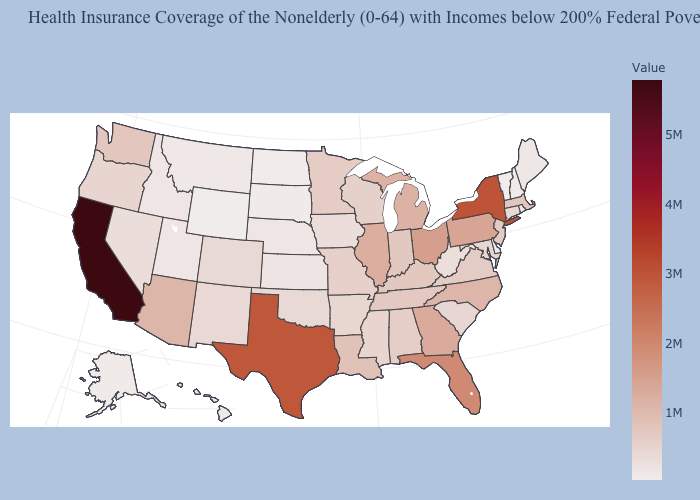Is the legend a continuous bar?
Be succinct. Yes. Which states hav the highest value in the MidWest?
Short answer required. Ohio. Does South Dakota have the highest value in the MidWest?
Give a very brief answer. No. Does the map have missing data?
Short answer required. No. Among the states that border Vermont , does Massachusetts have the lowest value?
Short answer required. No. 